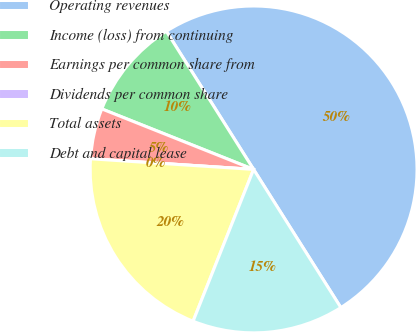Convert chart. <chart><loc_0><loc_0><loc_500><loc_500><pie_chart><fcel>Operating revenues<fcel>Income (loss) from continuing<fcel>Earnings per common share from<fcel>Dividends per common share<fcel>Total assets<fcel>Debt and capital lease<nl><fcel>50.0%<fcel>10.0%<fcel>5.0%<fcel>0.0%<fcel>20.0%<fcel>15.0%<nl></chart> 